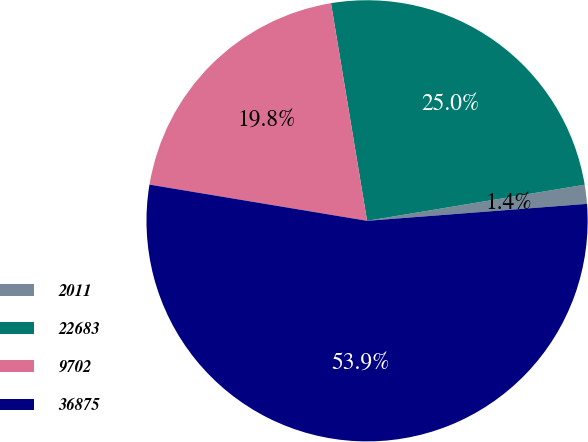<chart> <loc_0><loc_0><loc_500><loc_500><pie_chart><fcel>2011<fcel>22683<fcel>9702<fcel>36875<nl><fcel>1.39%<fcel>25.0%<fcel>19.76%<fcel>53.85%<nl></chart> 